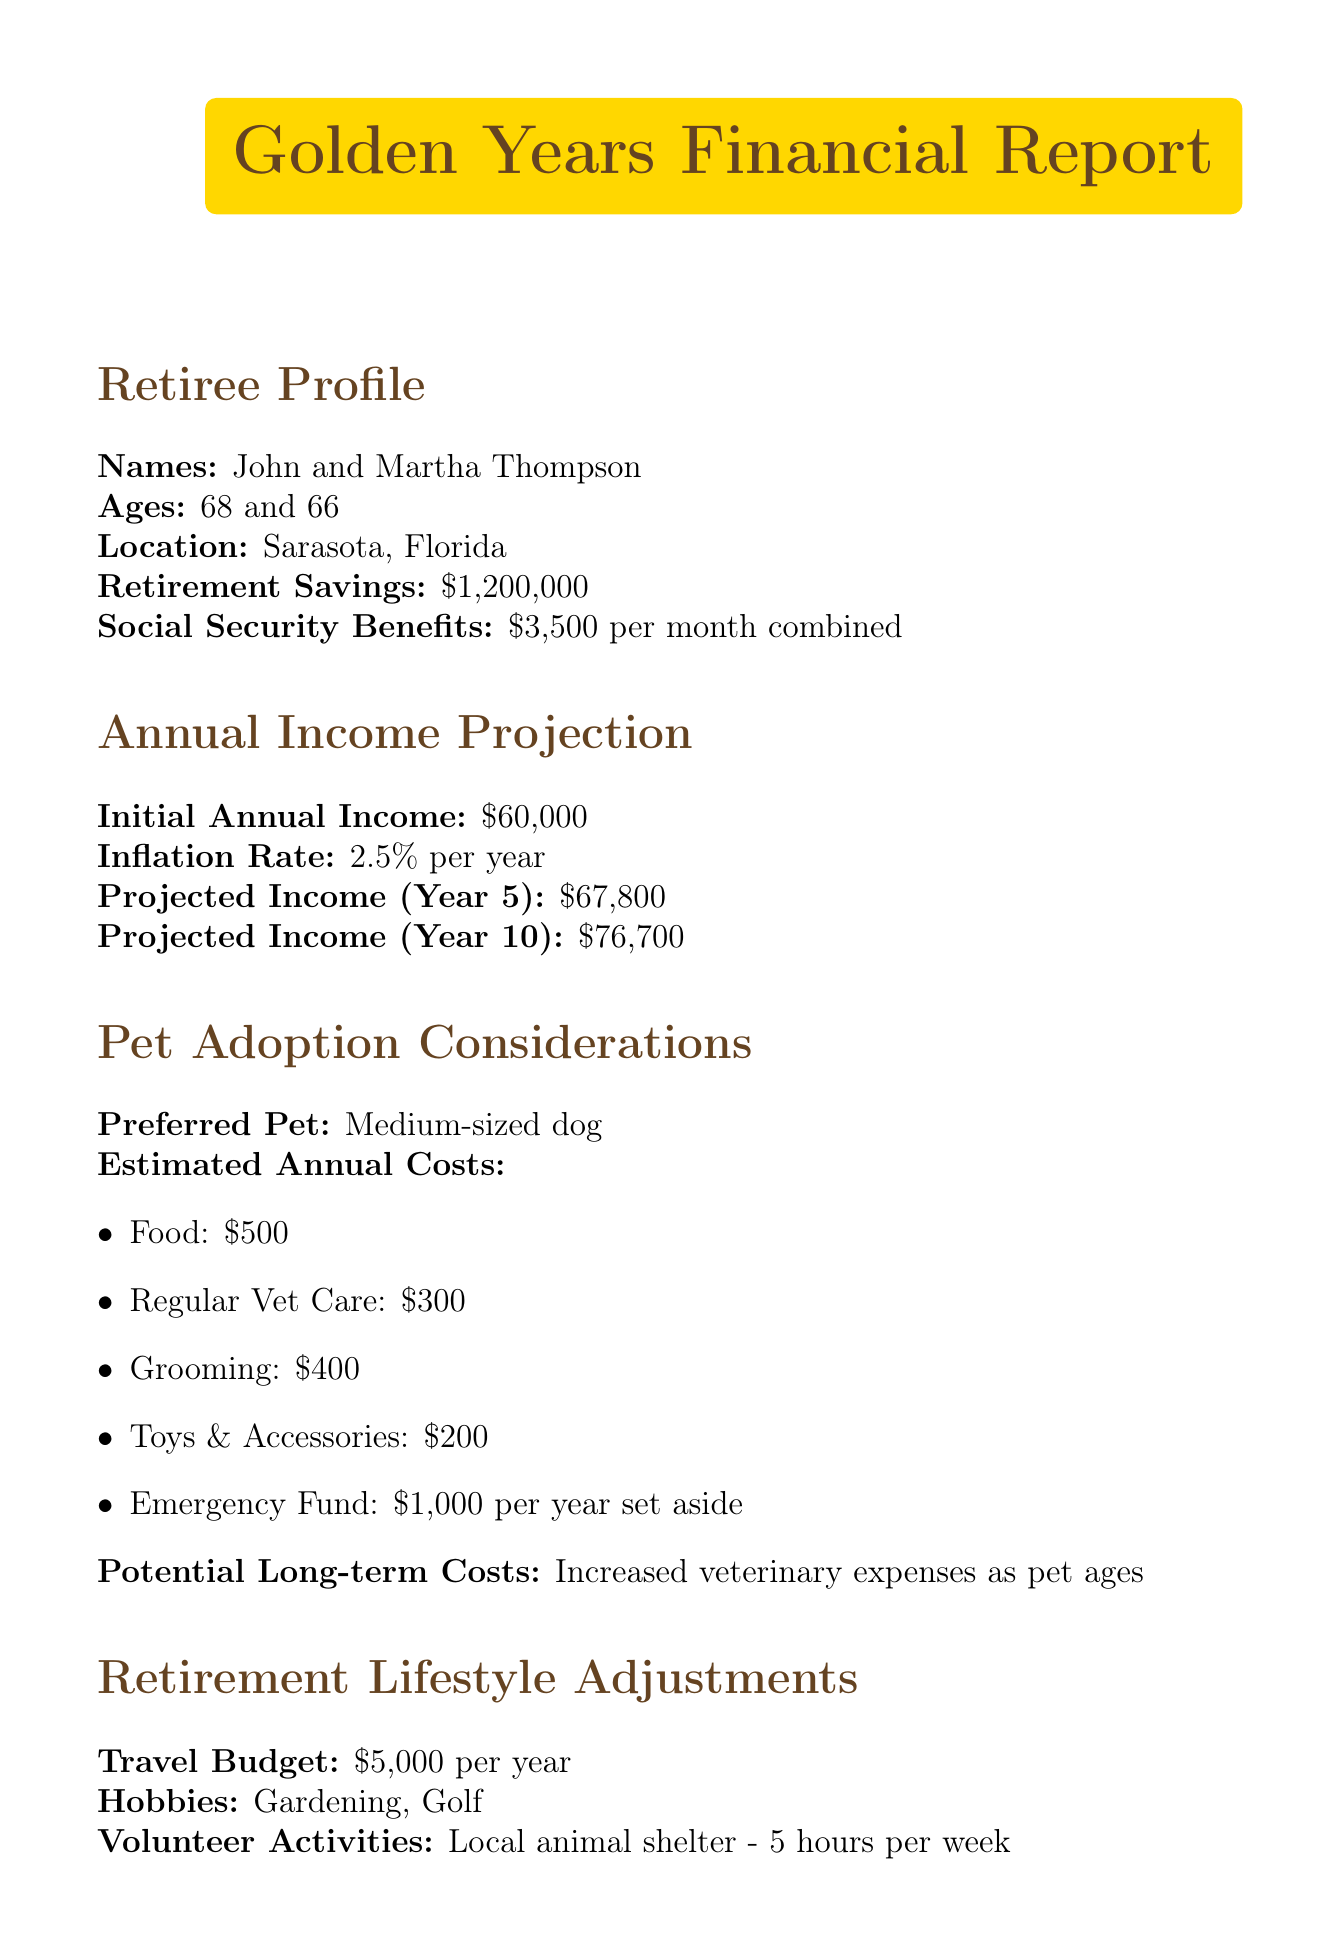What are the names of the retirees? The document lists the names of the retirees as John and Martha Thompson.
Answer: John and Martha Thompson What is the retirement savings amount? The retirement savings amount indicated in the document is $1,200,000.
Answer: $1,200,000 What is the initial annual income projected? The initial annual income projected is stated as $60,000 in the document.
Answer: $60,000 What is the estimated annual cost for grooming? The document specifies that the estimated annual cost for grooming is $400.
Answer: $400 What is the projected income in Year 10? According to the document, the projected income in Year 10 is $76,700.
Answer: $76,700 How much is set aside annually for emergencies related to pet care? The emergency fund set aside annually for pet care is $1,000, as noted in the document.
Answer: $1,000 What investment strategy is recommended? The financial advisor recommends a conservative growth investment strategy focusing on dividend-paying stocks.
Answer: Conservative growth with focus on dividend-paying stocks What is the travel budget per year? The annual travel budget mentioned in the document is $5,000.
Answer: $5,000 What type of pet is preferred? The document indicates that the preferred pet type is a medium-sized dog.
Answer: Medium-sized dog 